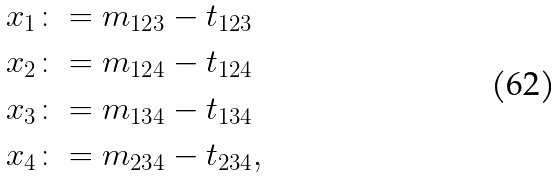<formula> <loc_0><loc_0><loc_500><loc_500>x _ { 1 } & \colon = m _ { 1 2 3 } - t _ { 1 2 3 } \\ x _ { 2 } & \colon = m _ { 1 2 4 } - t _ { 1 2 4 } \\ x _ { 3 } & \colon = m _ { 1 3 4 } - t _ { 1 3 4 } \\ x _ { 4 } & \colon = m _ { 2 3 4 } - t _ { 2 3 4 } ,</formula> 